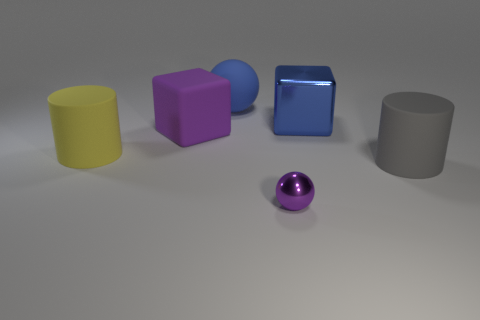Are there any other things that are the same size as the metal sphere?
Offer a terse response. No. How many objects are either large brown matte objects or large blue objects?
Give a very brief answer. 2. Are there any other purple cubes of the same size as the purple cube?
Ensure brevity in your answer.  No. There is a tiny purple metal thing; what shape is it?
Ensure brevity in your answer.  Sphere. Are there more gray cylinders behind the big rubber cube than tiny things that are behind the large gray object?
Keep it short and to the point. No. There is a sphere behind the large gray object; does it have the same color as the big rubber cylinder on the right side of the tiny purple metallic object?
Make the answer very short. No. There is a yellow object that is the same size as the shiny block; what shape is it?
Keep it short and to the point. Cylinder. Are there any other gray things of the same shape as the big shiny object?
Offer a very short reply. No. Is the material of the ball that is in front of the yellow thing the same as the large ball behind the big purple rubber thing?
Keep it short and to the point. No. What shape is the object that is the same color as the big matte cube?
Keep it short and to the point. Sphere. 